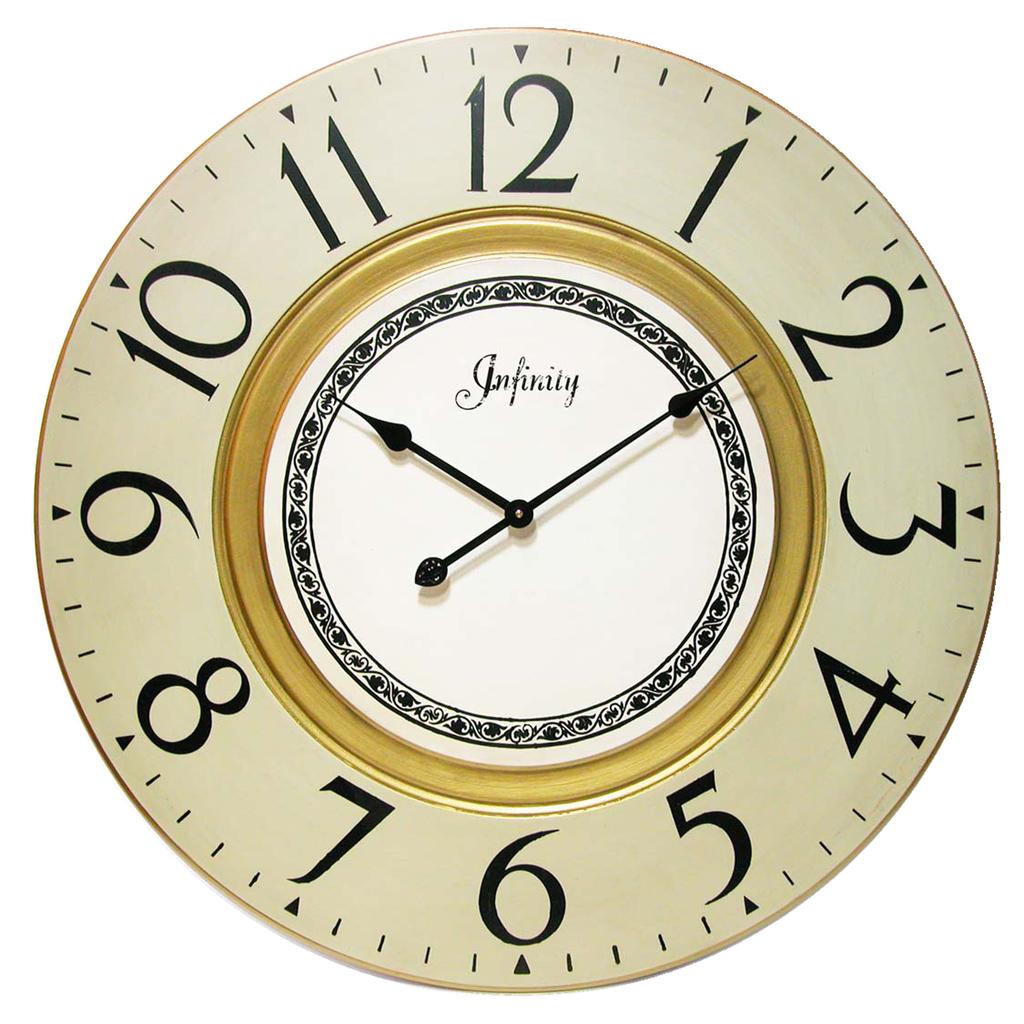What does the writing in the middle mean?
Your answer should be very brief. Infinity. What time is it?
Your answer should be very brief. 10:10. 